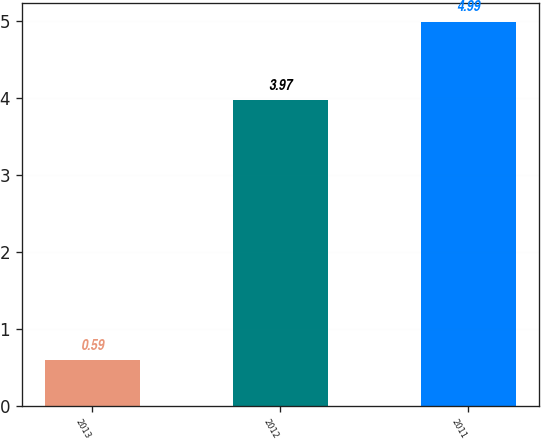Convert chart to OTSL. <chart><loc_0><loc_0><loc_500><loc_500><bar_chart><fcel>2013<fcel>2012<fcel>2011<nl><fcel>0.59<fcel>3.97<fcel>4.99<nl></chart> 